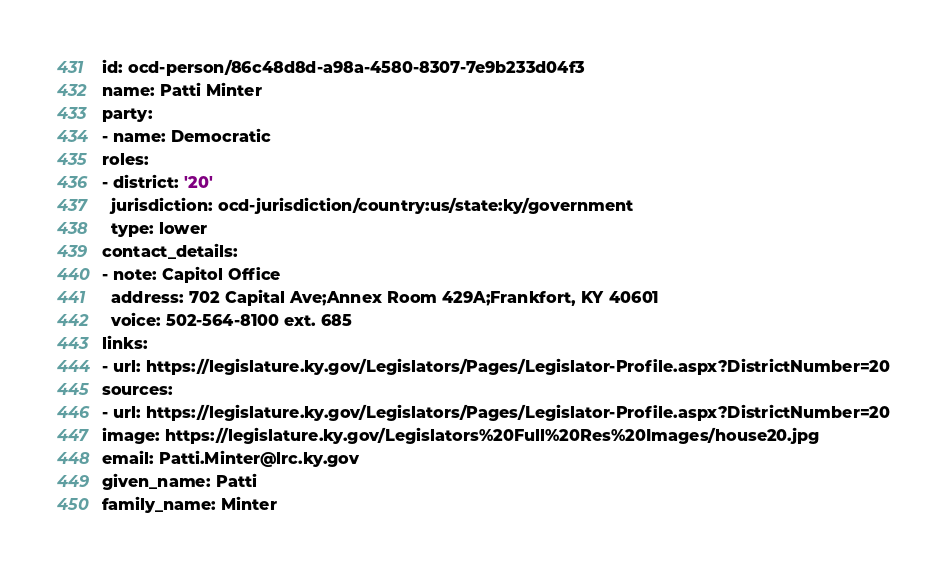Convert code to text. <code><loc_0><loc_0><loc_500><loc_500><_YAML_>id: ocd-person/86c48d8d-a98a-4580-8307-7e9b233d04f3
name: Patti Minter
party:
- name: Democratic
roles:
- district: '20'
  jurisdiction: ocd-jurisdiction/country:us/state:ky/government
  type: lower
contact_details:
- note: Capitol Office
  address: 702 Capital Ave;Annex Room 429A;Frankfort, KY 40601
  voice: 502-564-8100 ext. 685
links:
- url: https://legislature.ky.gov/Legislators/Pages/Legislator-Profile.aspx?DistrictNumber=20
sources:
- url: https://legislature.ky.gov/Legislators/Pages/Legislator-Profile.aspx?DistrictNumber=20
image: https://legislature.ky.gov/Legislators%20Full%20Res%20Images/house20.jpg
email: Patti.Minter@lrc.ky.gov
given_name: Patti
family_name: Minter
</code> 